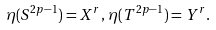<formula> <loc_0><loc_0><loc_500><loc_500>\eta ( S ^ { 2 p - 1 } ) = X ^ { r } , \, \eta ( T ^ { 2 p - 1 } ) = Y ^ { r } .</formula> 